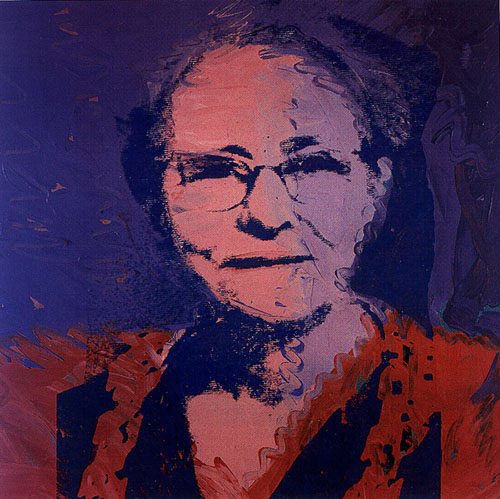Imagine a dream inspired by this portrait. What would it be like? In a dream inspired by this portrait, the woman might be seen wandering through a surreal landscape where colors dance and merge around her. Each step she takes leaves a trail of vibrant hues, transforming the environment into a living canvas. She encounters various abstract figures, each resonating with the emotions and experiences she has faced in life. As she moves, her surroundings shift and evolve, reflecting her inner journey of self-discovery and acceptance. The dream would be a beautiful blend of reality and imagination, filled with vivid imagery and profound symbolism. Can you create a short story based on the woman in the portrait? Once upon a time, in a quiet town, lived a woman named Eleanor. Her vibrant personality was renowned among all who knew her, yet she carried an air of mystery. The local artist captured her essence in a magnificent portrait, blending traditional techniques with abstract elements to create a mesmerizing piece of art. One day, elephants and gazelles appeared in the town's square. Their dance seemed to be guided by an invisible force, a whimsical tune that only they could hear. Eleanor watched with curiosity, her heart filled with a mix of wonder and nostalgia. She realized that these were manifestations of her memories—moments, dreams, and encounters that had shaped her life. In that instant, Eleanor felt a deep connection to the world around her, a sense of unity and purpose. The next day, the animals were gone, but the memory of their dance lingered, a reminder of the beauty and complexity of her existence. 